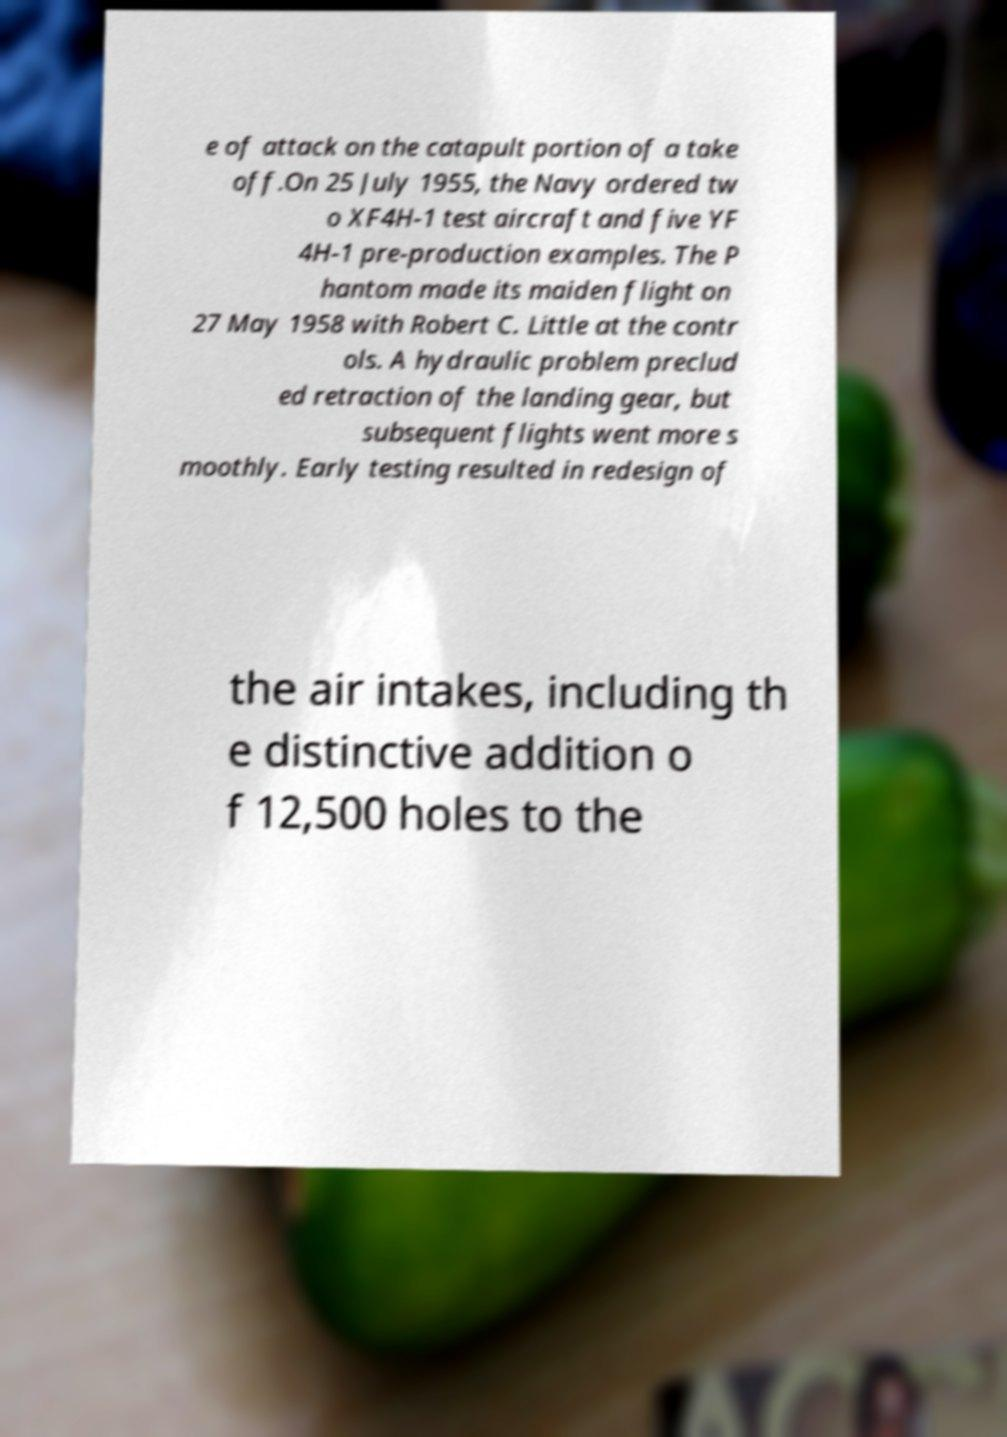Could you assist in decoding the text presented in this image and type it out clearly? e of attack on the catapult portion of a take off.On 25 July 1955, the Navy ordered tw o XF4H-1 test aircraft and five YF 4H-1 pre-production examples. The P hantom made its maiden flight on 27 May 1958 with Robert C. Little at the contr ols. A hydraulic problem preclud ed retraction of the landing gear, but subsequent flights went more s moothly. Early testing resulted in redesign of the air intakes, including th e distinctive addition o f 12,500 holes to the 